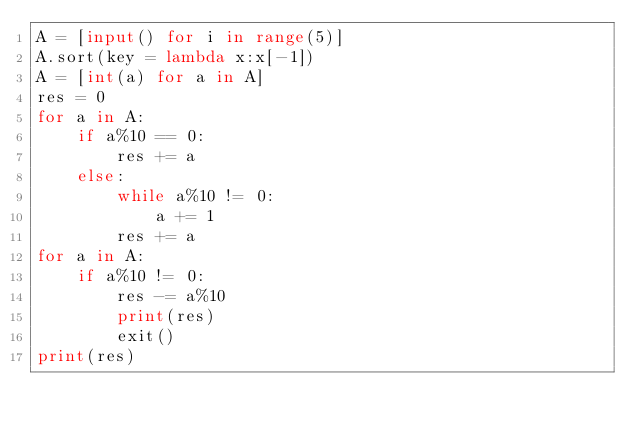<code> <loc_0><loc_0><loc_500><loc_500><_Python_>A = [input() for i in range(5)]
A.sort(key = lambda x:x[-1])
A = [int(a) for a in A]
res = 0
for a in A:
	if a%10 == 0:
		res += a
	else:
		while a%10 != 0:
			a += 1
		res += a 
for a in A:
	if a%10 != 0:
		res -= a%10
		print(res)
		exit()
print(res)</code> 